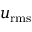<formula> <loc_0><loc_0><loc_500><loc_500>u _ { r m s }</formula> 